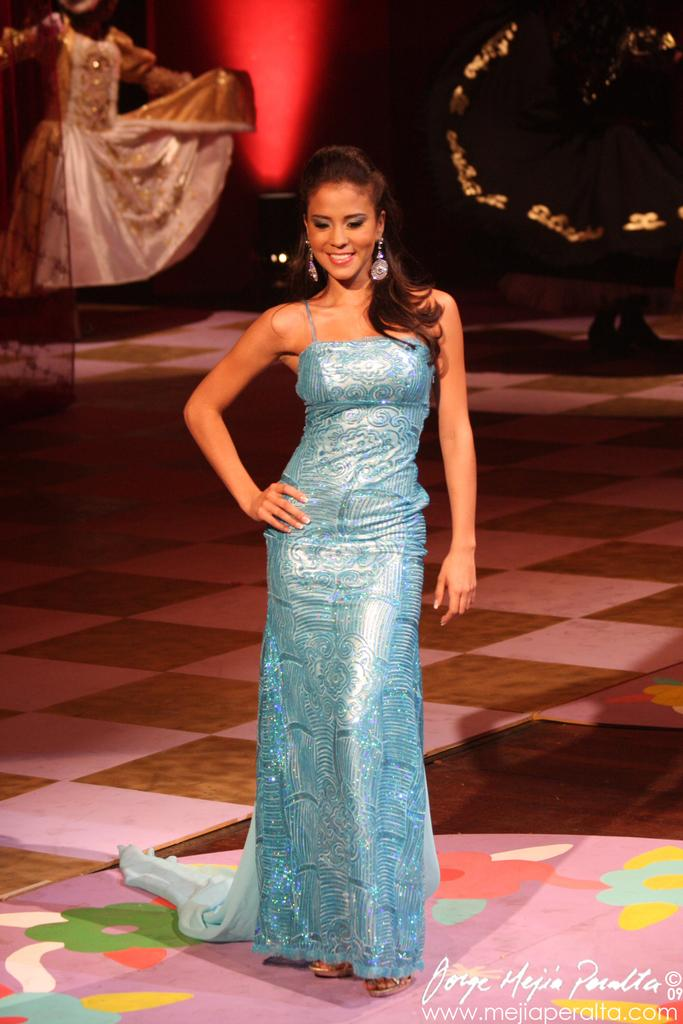What is the main subject of the image? The main subject of the image is a woman. Where is the woman positioned in the image? The woman is standing in the middle of the image. What expression does the woman have? The woman is smiling. Are there any other people in the image? Yes, there are two other persons behind the woman. What type of pump can be seen in the image? There is no pump present in the image. Can you tell me how many donkeys are visible in the image? There are no donkeys visible in the image. 